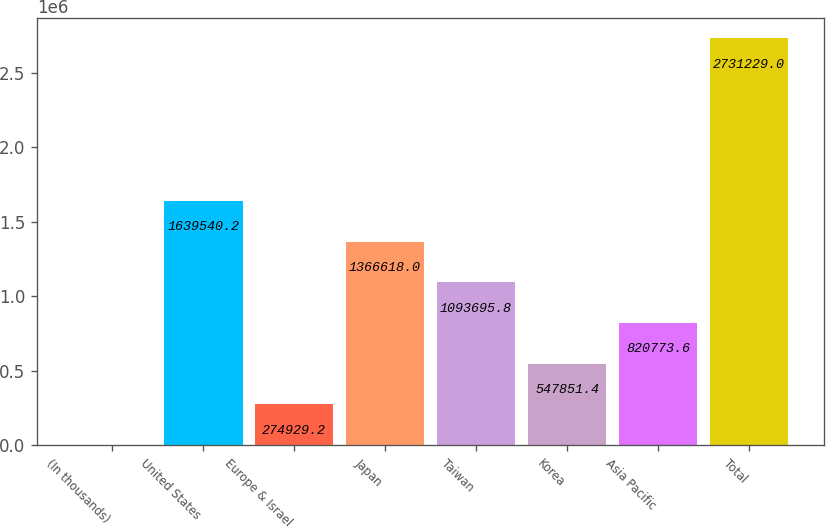Convert chart. <chart><loc_0><loc_0><loc_500><loc_500><bar_chart><fcel>(In thousands)<fcel>United States<fcel>Europe & Israel<fcel>Japan<fcel>Taiwan<fcel>Korea<fcel>Asia Pacific<fcel>Total<nl><fcel>2007<fcel>1.63954e+06<fcel>274929<fcel>1.36662e+06<fcel>1.0937e+06<fcel>547851<fcel>820774<fcel>2.73123e+06<nl></chart> 